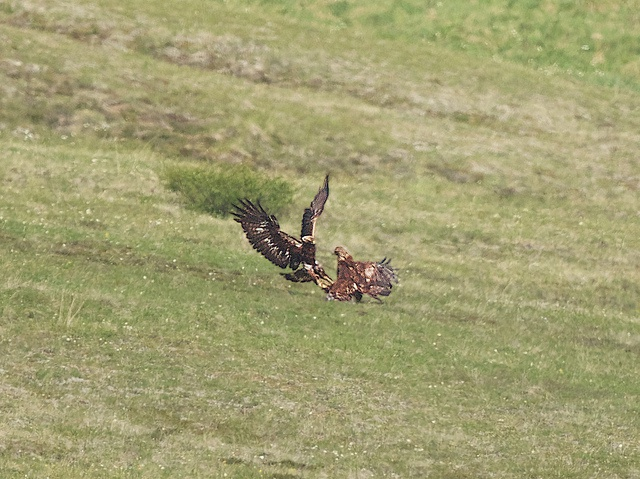Describe the objects in this image and their specific colors. I can see bird in tan, black, and gray tones and bird in tan, gray, brown, and maroon tones in this image. 